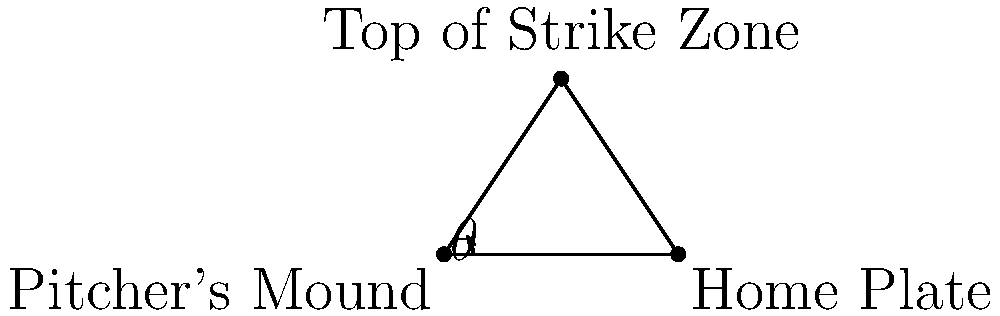As the coach, you're explaining the strike zone to your young pitchers. If the distance from the pitcher's mound to home plate is 60 feet, and the top of the strike zone is 4 feet above home plate, what is the angle $\theta$ (in degrees) that the pitcher needs to aim at to hit the top of the strike zone? Let's approach this step-by-step:

1) We can treat this as a right triangle problem. The pitcher's mound is at one vertex, home plate at another, and the top of the strike zone forms the third vertex.

2) We know two sides of this triangle:
   - The base (distance from pitcher's mound to home plate) = 60 feet
   - The height (height of the top of the strike zone) = 4 feet

3) To find the angle $\theta$, we can use the arctangent function:

   $$\theta = \arctan(\frac{\text{opposite}}{\text{adjacent}})$$

4) In this case:
   - Opposite side = 4 feet (height of strike zone)
   - Adjacent side = 60 feet (distance to home plate)

5) Plugging these values into the formula:

   $$\theta = \arctan(\frac{4}{60})$$

6) Simplify the fraction:

   $$\theta = \arctan(\frac{1}{15})$$

7) Using a calculator or trigonometric tables:

   $$\theta \approx 3.81^\circ$$

8) Rounding to two decimal places:

   $$\theta \approx 3.81^\circ$$

This is the angle above horizontal that the pitcher needs to aim to hit the top of the strike zone.
Answer: $3.81^\circ$ 